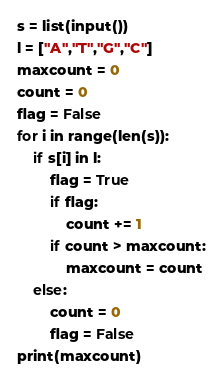Convert code to text. <code><loc_0><loc_0><loc_500><loc_500><_Python_>s = list(input())
l = ["A","T","G","C"]
maxcount = 0
count = 0
flag = False
for i in range(len(s)):
    if s[i] in l:
        flag = True
        if flag:
            count += 1
        if count > maxcount:
            maxcount = count
    else:
        count = 0
        flag = False
print(maxcount)</code> 